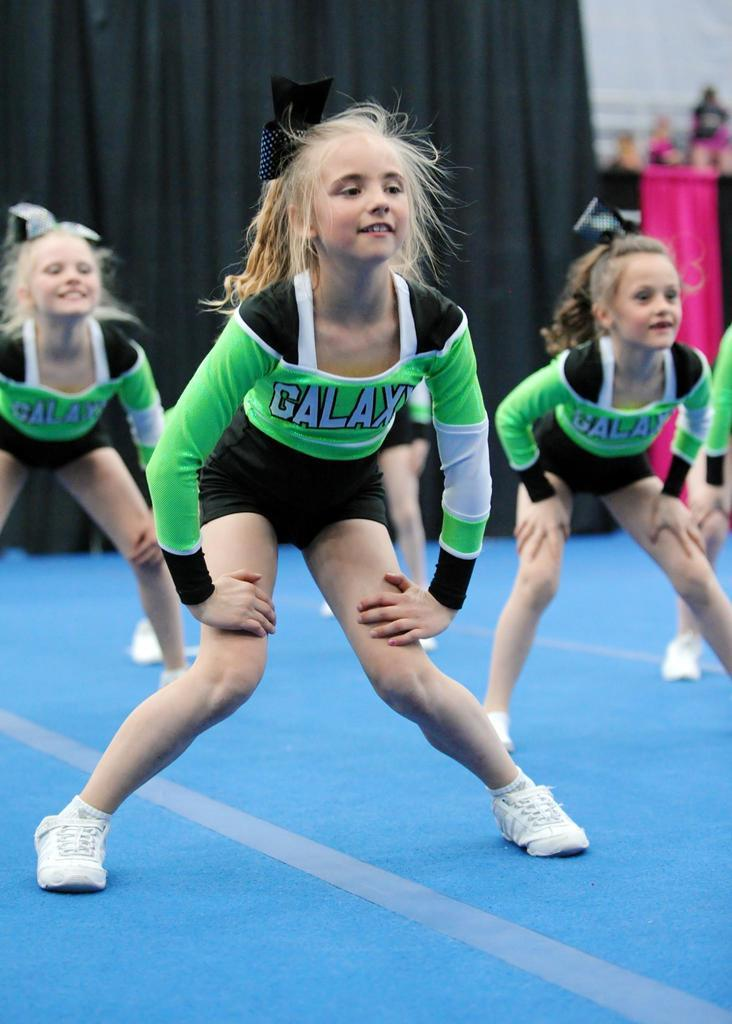<image>
Describe the image concisely. the girls are cheerleaders from the galaxy team 